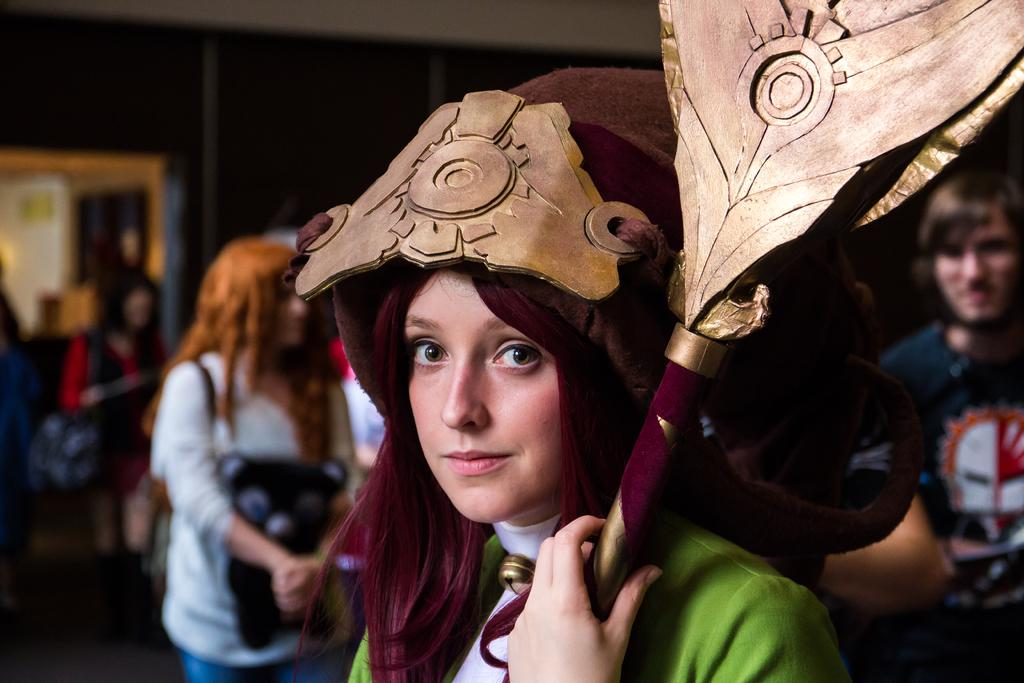What is the woman doing in the image? The woman is standing in the image. What is the woman holding in her hand? The woman is holding an object in her hand. How is the woman dressed in the image? The woman is wearing a fancy dress. What can be seen in the background of the image? There are groups of people in the background of the image. What is the woman's belief about the end of the world in the image? There is no information about the woman's beliefs or the end of the world in the image. 